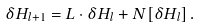Convert formula to latex. <formula><loc_0><loc_0><loc_500><loc_500>\delta H _ { l + 1 } = L \cdot \delta H _ { l } + N [ \delta H _ { l } ] \, .</formula> 